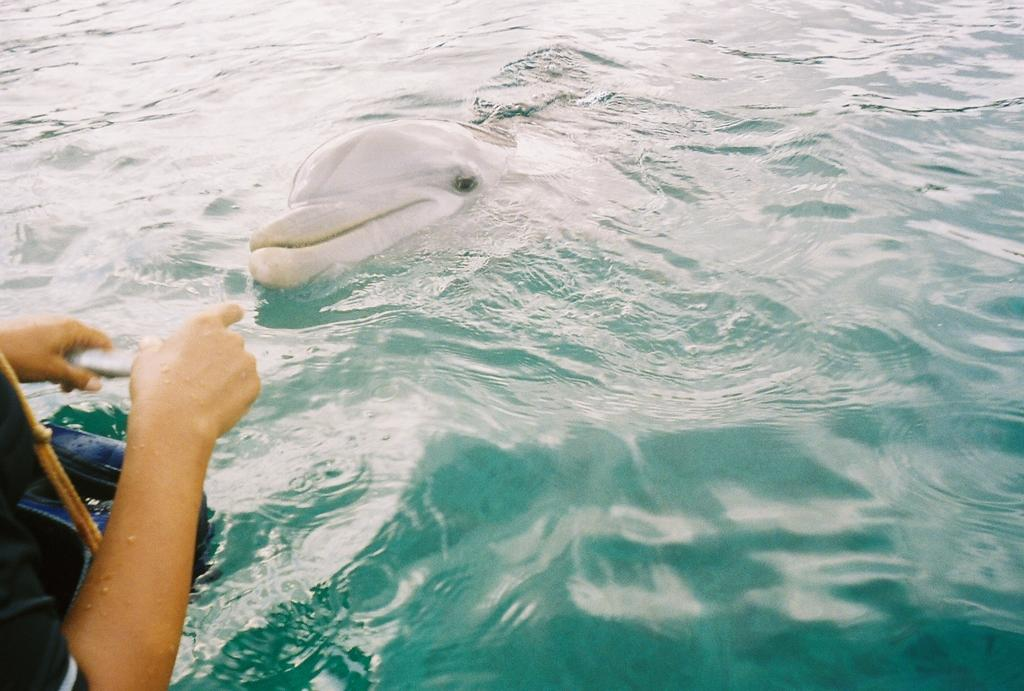What type of animal is in the image? There is a white color dolphin in the image. Where is the dolphin located? The dolphin is in water. Can you describe any other elements in the image? There is a person's hand visible in the image. What size wheel can be seen attached to the dolphin in the image? There is no wheel present in the image, as it features a dolphin in water and dolphins do not have wheels. 